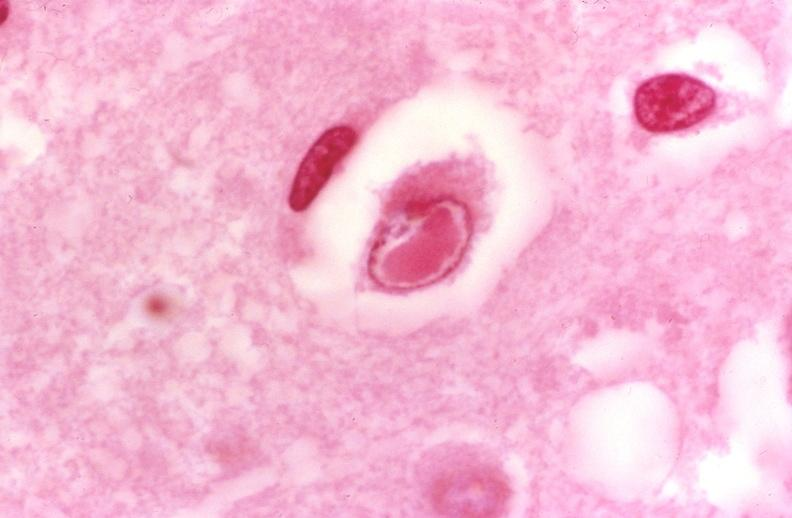s nervous present?
Answer the question using a single word or phrase. Yes 